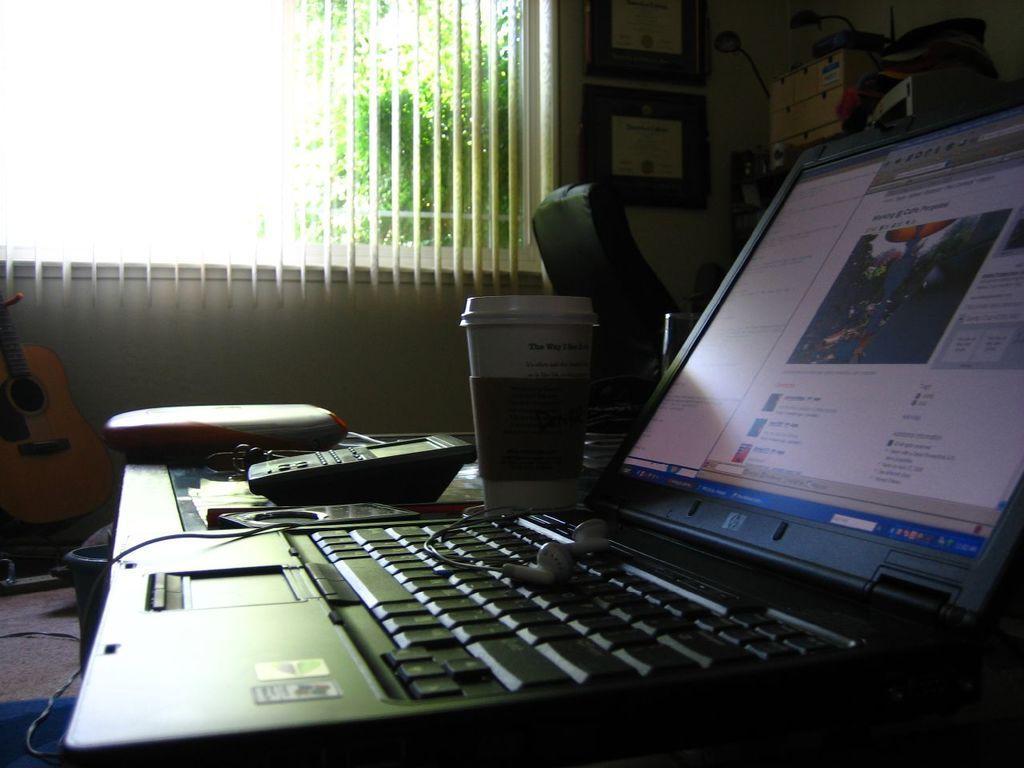In one or two sentences, can you explain what this image depicts? In the image in the center we can see table,on table we can see tab,earphones etc. Back we can see window,photo frame,machine ,wall,trees,guitar etc. 